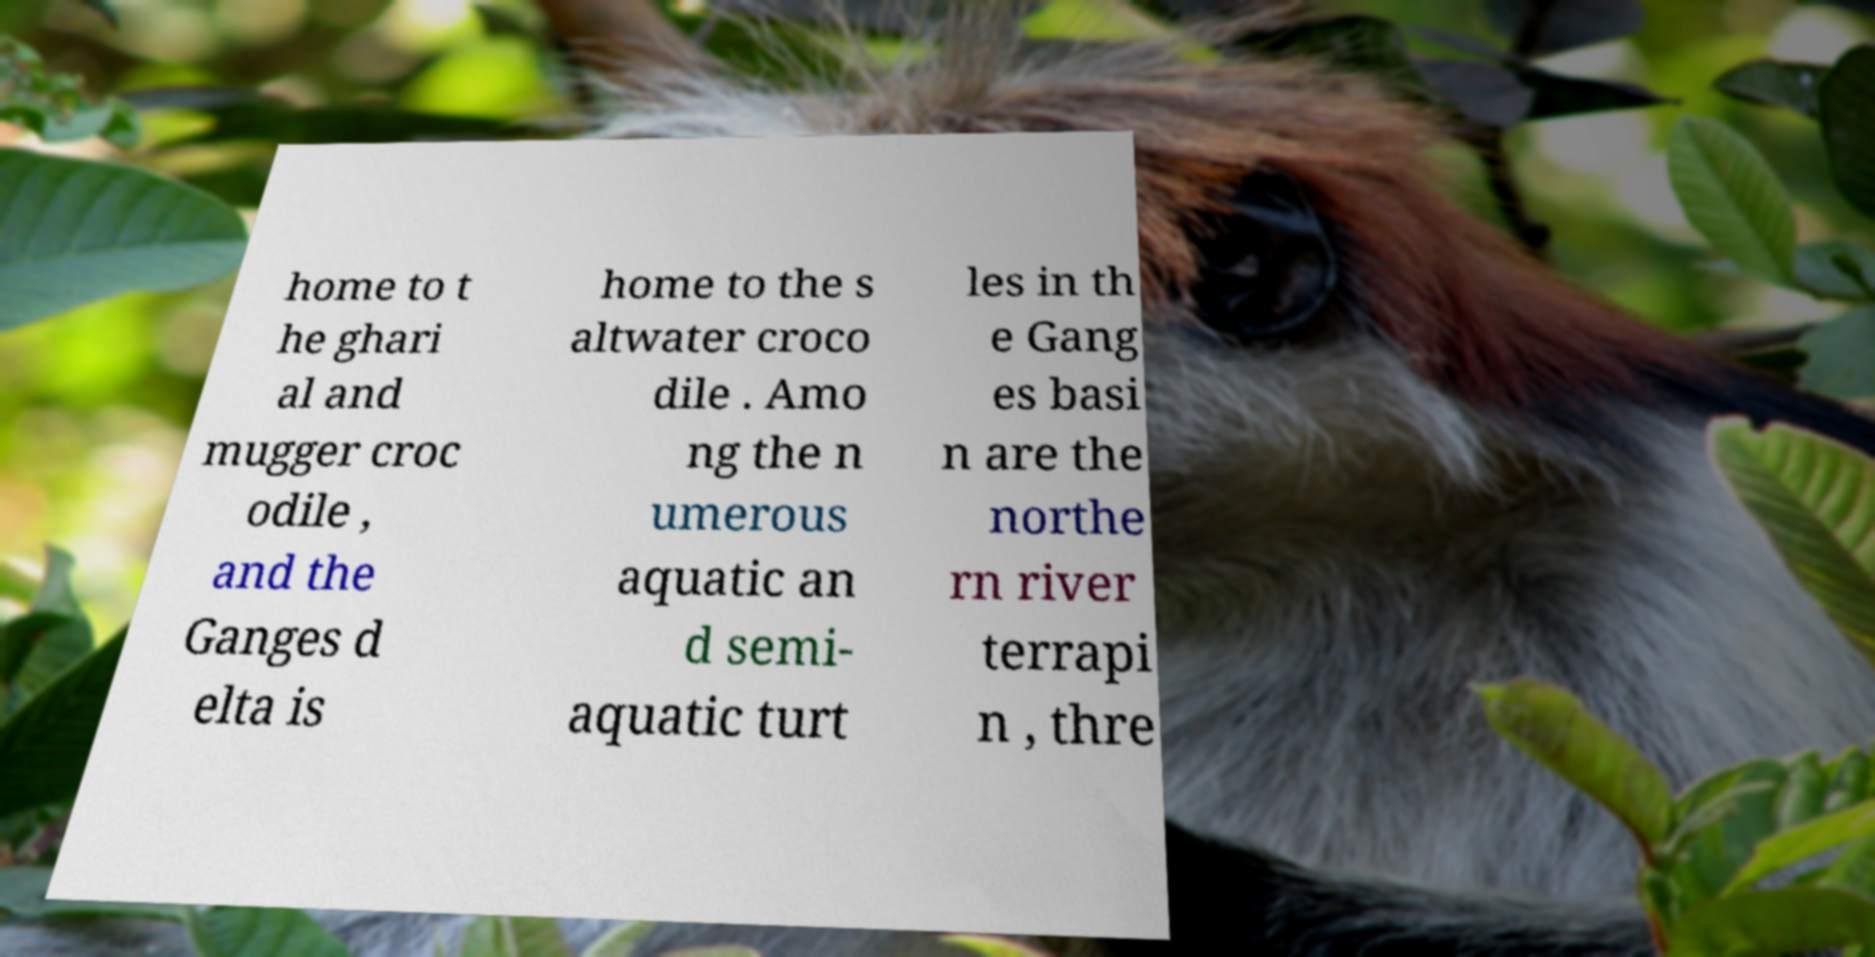Please read and relay the text visible in this image. What does it say? home to t he ghari al and mugger croc odile , and the Ganges d elta is home to the s altwater croco dile . Amo ng the n umerous aquatic an d semi- aquatic turt les in th e Gang es basi n are the northe rn river terrapi n , thre 